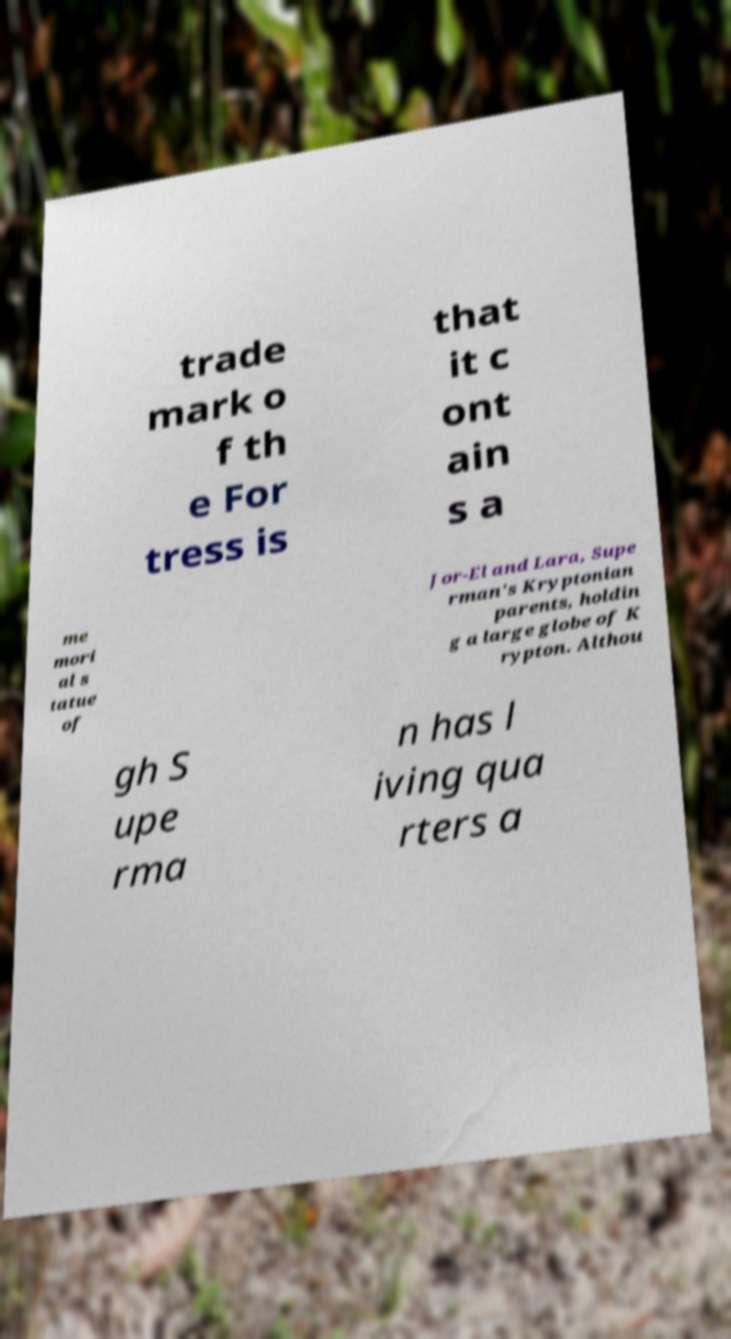Please identify and transcribe the text found in this image. trade mark o f th e For tress is that it c ont ain s a me mori al s tatue of Jor-El and Lara, Supe rman's Kryptonian parents, holdin g a large globe of K rypton. Althou gh S upe rma n has l iving qua rters a 